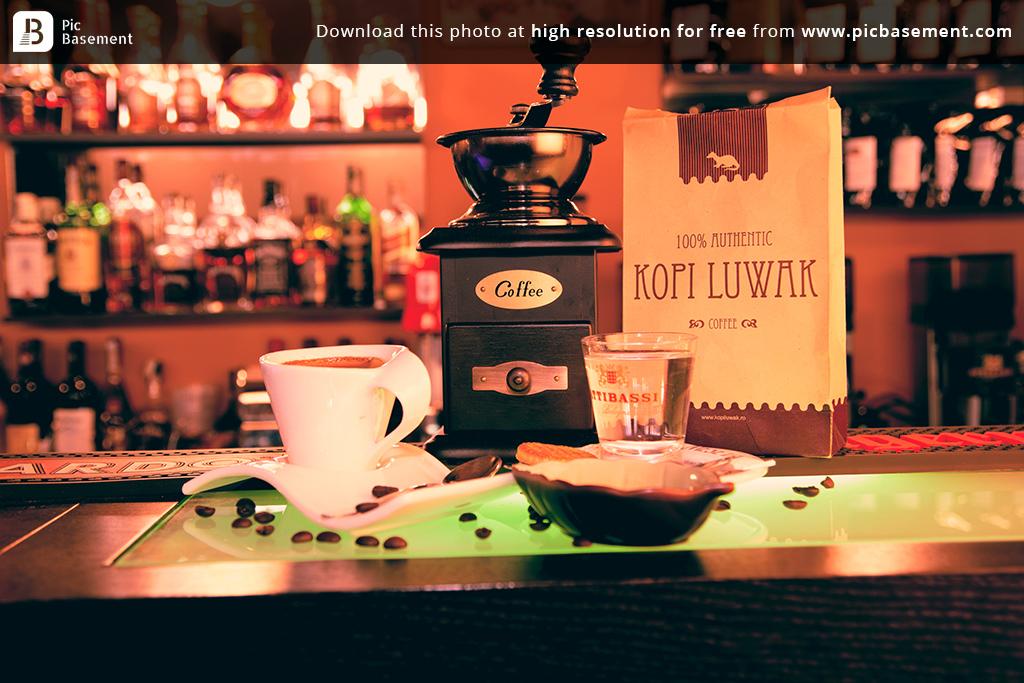What brand of coffee is in the bag?
Your answer should be very brief. Kopi luwak. 